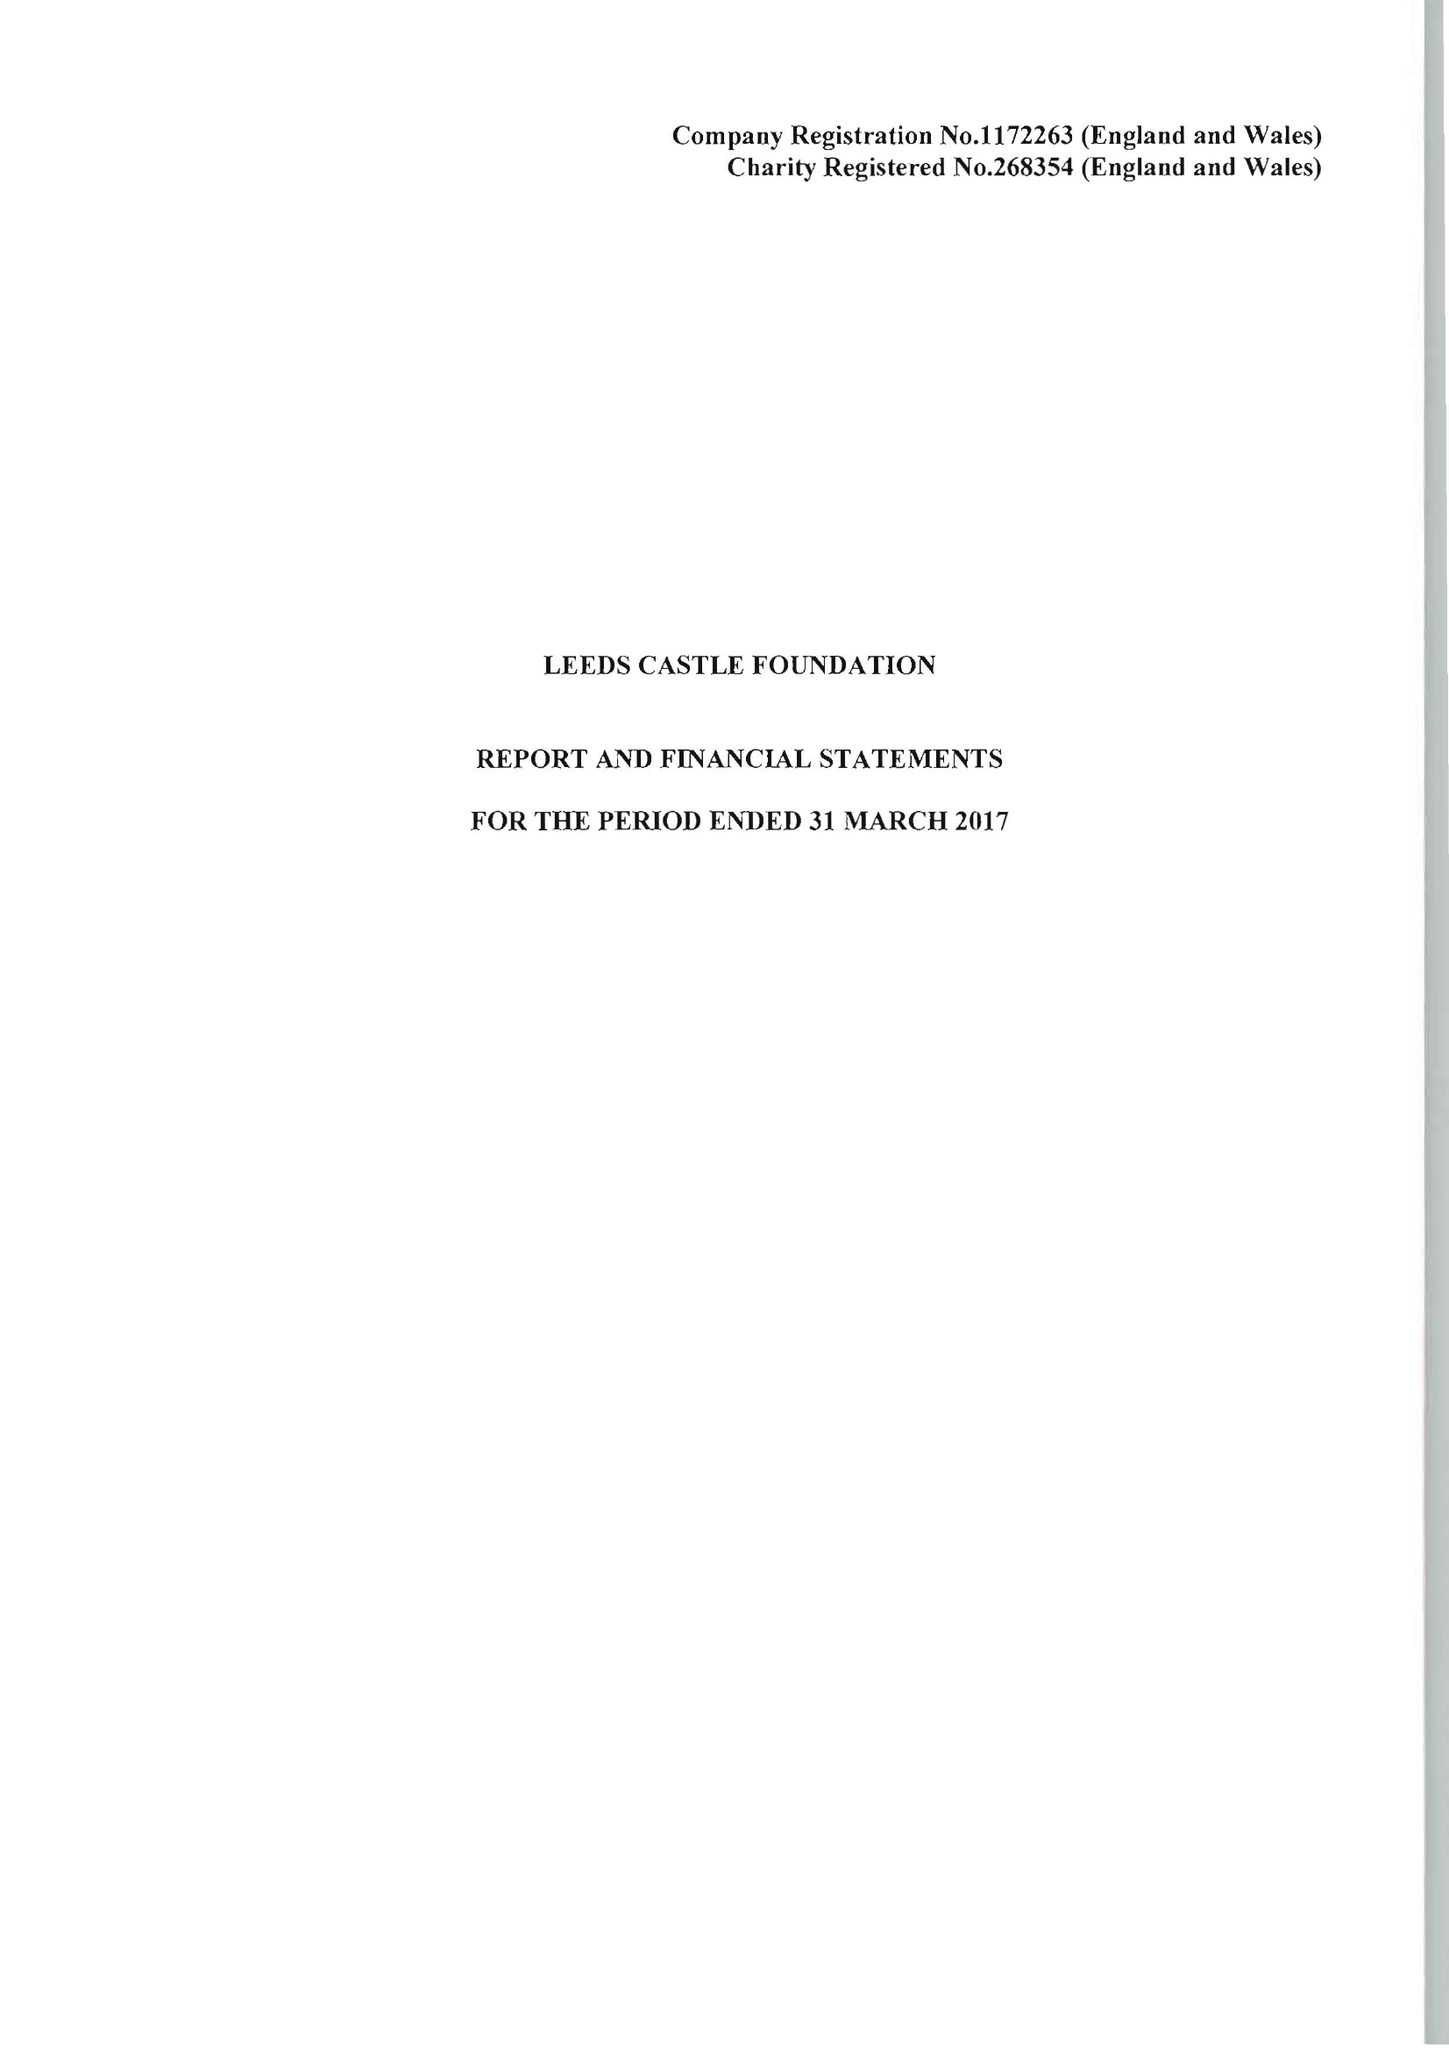What is the value for the address__postcode?
Answer the question using a single word or phrase. ME17 1PL 